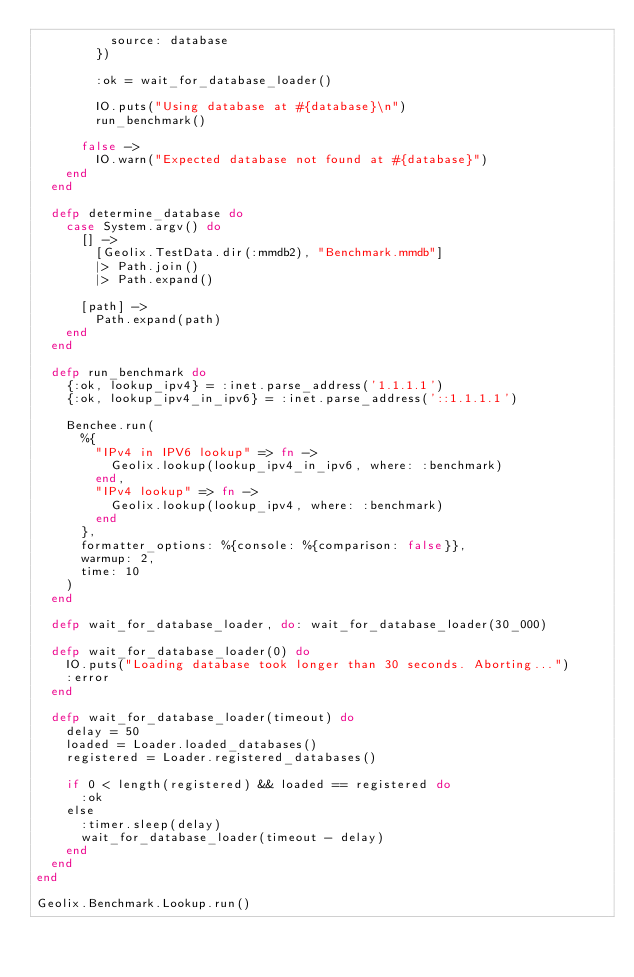<code> <loc_0><loc_0><loc_500><loc_500><_Elixir_>          source: database
        })

        :ok = wait_for_database_loader()

        IO.puts("Using database at #{database}\n")
        run_benchmark()

      false ->
        IO.warn("Expected database not found at #{database}")
    end
  end

  defp determine_database do
    case System.argv() do
      [] ->
        [Geolix.TestData.dir(:mmdb2), "Benchmark.mmdb"]
        |> Path.join()
        |> Path.expand()

      [path] ->
        Path.expand(path)
    end
  end

  defp run_benchmark do
    {:ok, lookup_ipv4} = :inet.parse_address('1.1.1.1')
    {:ok, lookup_ipv4_in_ipv6} = :inet.parse_address('::1.1.1.1')

    Benchee.run(
      %{
        "IPv4 in IPV6 lookup" => fn ->
          Geolix.lookup(lookup_ipv4_in_ipv6, where: :benchmark)
        end,
        "IPv4 lookup" => fn ->
          Geolix.lookup(lookup_ipv4, where: :benchmark)
        end
      },
      formatter_options: %{console: %{comparison: false}},
      warmup: 2,
      time: 10
    )
  end

  defp wait_for_database_loader, do: wait_for_database_loader(30_000)

  defp wait_for_database_loader(0) do
    IO.puts("Loading database took longer than 30 seconds. Aborting...")
    :error
  end

  defp wait_for_database_loader(timeout) do
    delay = 50
    loaded = Loader.loaded_databases()
    registered = Loader.registered_databases()

    if 0 < length(registered) && loaded == registered do
      :ok
    else
      :timer.sleep(delay)
      wait_for_database_loader(timeout - delay)
    end
  end
end

Geolix.Benchmark.Lookup.run()
</code> 